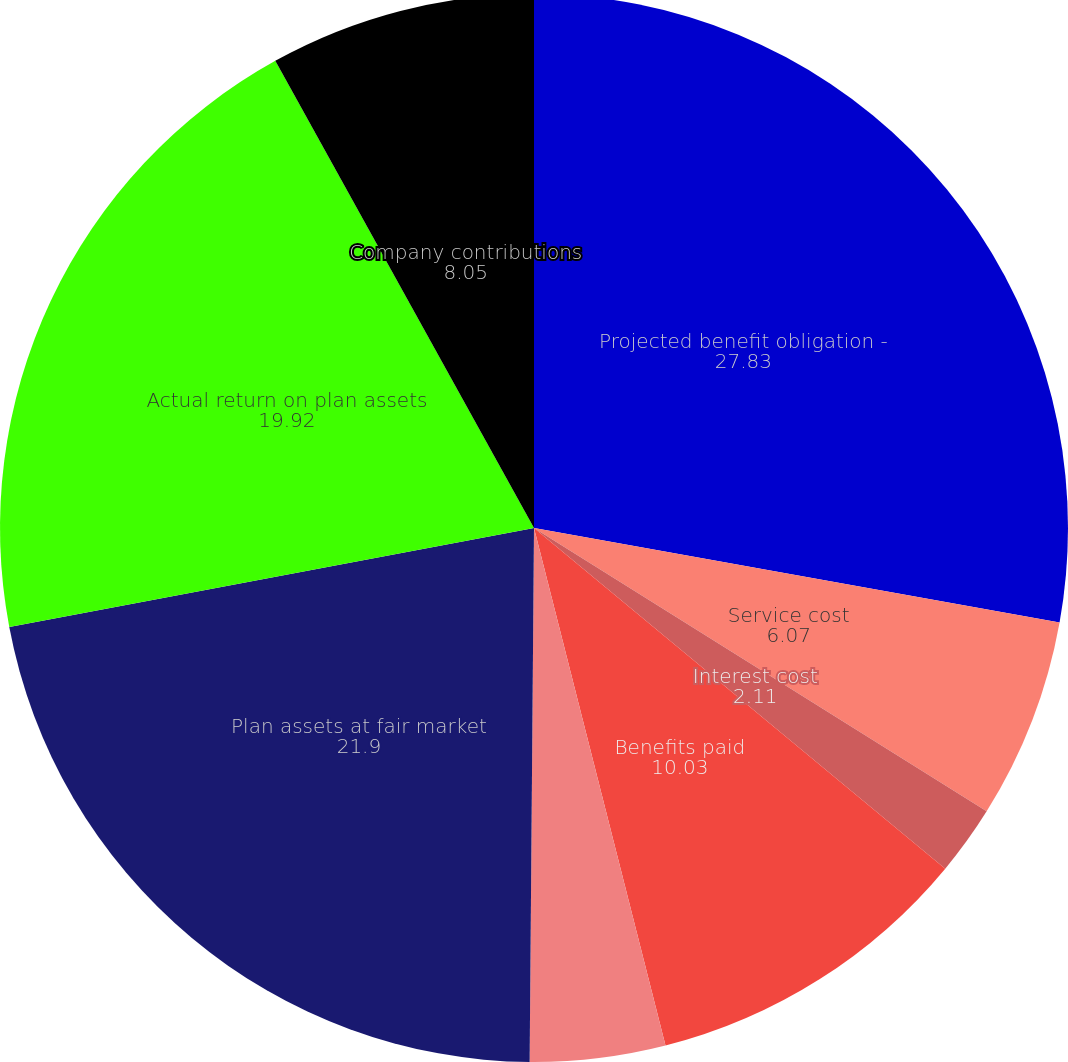Convert chart to OTSL. <chart><loc_0><loc_0><loc_500><loc_500><pie_chart><fcel>Projected benefit obligation -<fcel>Service cost<fcel>Interest cost<fcel>Benefits paid<fcel>Actuarial (gain) loss<fcel>Plan assets at fair market<fcel>Actual return on plan assets<fcel>Company contributions<nl><fcel>27.83%<fcel>6.07%<fcel>2.11%<fcel>10.03%<fcel>4.09%<fcel>21.9%<fcel>19.92%<fcel>8.05%<nl></chart> 